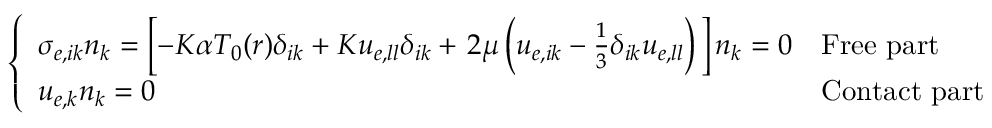<formula> <loc_0><loc_0><loc_500><loc_500>\left \{ \begin{array} { l l } { \sigma _ { e , i k } n _ { k } = \left [ - K \alpha T _ { 0 } ( r ) \delta _ { i k } + K u _ { e , l l } \delta _ { i k } + 2 \mu \left ( u _ { e , i k } - \frac { 1 } { 3 } \delta _ { i k } u _ { e , l l } \right ) \right ] n _ { k } = 0 } & { F r e e p a r t } \\ { u _ { e , k } n _ { k } = 0 } & { C o n t a c t p a r t } \end{array}</formula> 